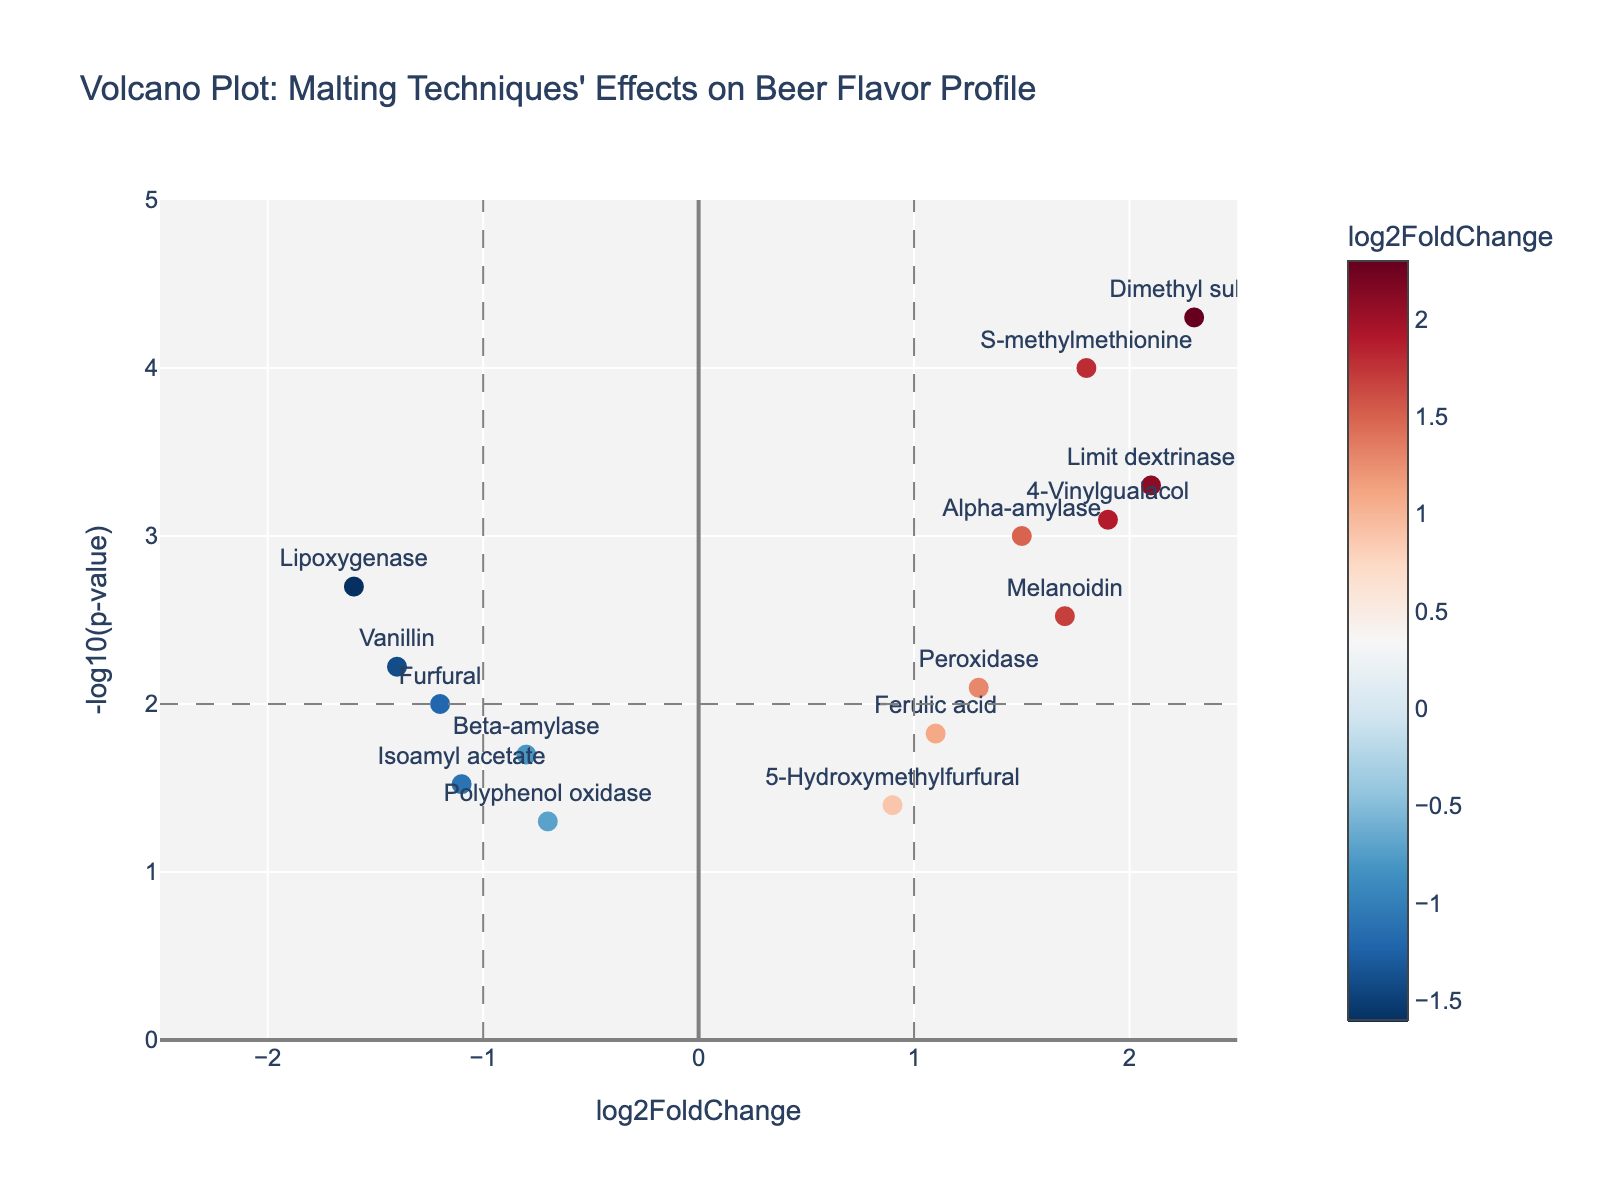What is the title of the figure? The title of the figure is located at the top and provides a brief overview of the plot contents. By looking at the title on the plot, we can interpret it directly.
Answer: Volcano Plot: Malting Techniques' Effects on Beer Flavor Profile How many data points are shown on the plot? Count the number of markers on the plot, each representing a data point. By moving your eyes across the plot and counting each point, we can determine the total.
Answer: 14 Which gene has the highest -log10(p-value)? Locate the point that is positioned highest on the y-axis, which corresponds to the greatest -log10(p-value). Identify the gene label associated with this point.
Answer: Dimethyl sulfide Which gene has the largest log2FoldChange? Identify the point farthest to the right on the x-axis, representing the maximum log2FoldChange. Check the gene label of this specific point.
Answer: Dimethyl sulfide How many genes have a log2FoldChange greater than 1 and a -log10(p-value) greater than 2? Locate the quadrant formed by the vertical line at log2FoldChange = 1 and the horizontal line at -log10(p-value) = 2. Count the number of points within this region.
Answer: 5 What color represents the log2FoldChange values on the markers? Look at the colorbar next to the plot which indicates the representation of log2FoldChange values. Identify the specific colors shown in the plot's markers.
Answer: A color gradient from blue to red Which gene has a significant log2FoldChange less than -1? Check points on the plot that are to the left of the vertical line at log2FoldChange = -1 and have a -log10(p-value) above 2, indicating significance. Identify the gene labels of these points.
Answer: Lipoxygenase What are the log2FoldChange and -log10(p-value) of the gene "Alpha-amylase"? Locate the point labeled "Alpha-amylase" on the plot. Identify its position coordinates on the x-axis (log2FoldChange) and the y-axis (-log10(p-value)).
Answer: log2FoldChange: 1.5, -log10(p-value): 3 Which genes are negatively affected by the malting techniques? Look for points that have a negative log2FoldChange value. Identify their corresponding gene labels.
Answer: Beta-amylase, Furfural, Lipoxygenase, Polyphenol oxidase, Vanillin, Isoamyl acetate How many genes have p-values less than 0.01? -log10(0.01) equals 2, so identify points above y=2 on the plot since this indicates p-values below 0.01. Count these points.
Answer: 9 